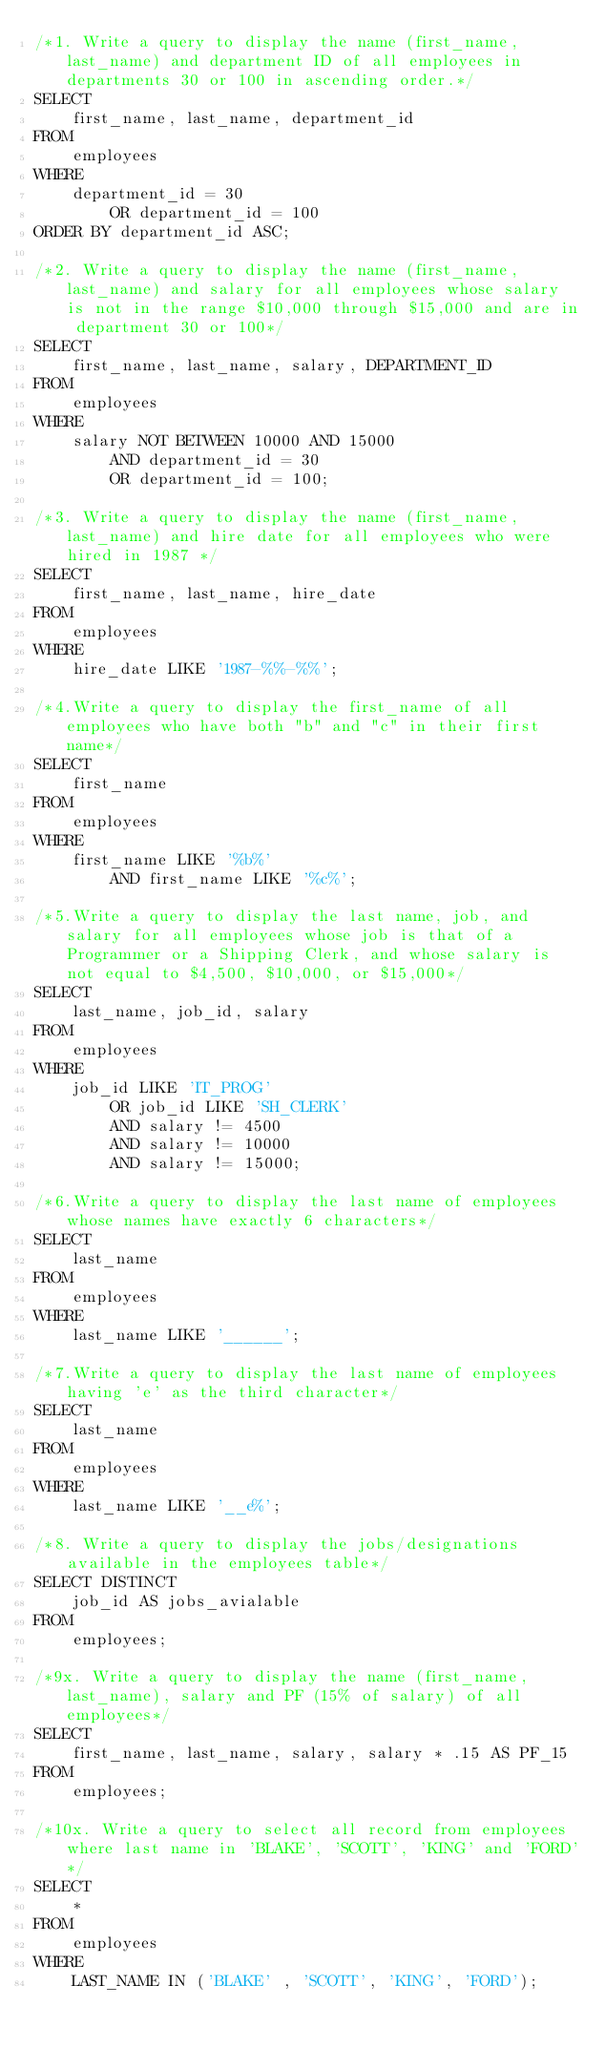<code> <loc_0><loc_0><loc_500><loc_500><_SQL_>/*1. Write a query to display the name (first_name, last_name) and department ID of all employees in departments 30 or 100 in ascending order.*/
SELECT 
    first_name, last_name, department_id
FROM
    employees
WHERE
    department_id = 30
        OR department_id = 100
ORDER BY department_id ASC;

/*2. Write a query to display the name (first_name, last_name) and salary for all employees whose salary is not in the range $10,000 through $15,000 and are in department 30 or 100*/
SELECT 
    first_name, last_name, salary, DEPARTMENT_ID
FROM
    employees
WHERE
    salary NOT BETWEEN 10000 AND 15000
        AND department_id = 30
        OR department_id = 100;
        
/*3. Write a query to display the name (first_name, last_name) and hire date for all employees who were hired in 1987 */
SELECT 
    first_name, last_name, hire_date
FROM
    employees
WHERE
    hire_date LIKE '1987-%%-%%';

/*4.Write a query to display the first_name of all employees who have both "b" and "c" in their first name*/
SELECT 
    first_name
FROM
    employees
WHERE
    first_name LIKE '%b%'
        AND first_name LIKE '%c%';
        
/*5.Write a query to display the last name, job, and salary for all employees whose job is that of a Programmer or a Shipping Clerk, and whose salary is not equal to $4,500, $10,000, or $15,000*/
SELECT 
    last_name, job_id, salary
FROM
    employees
WHERE
    job_id LIKE 'IT_PROG'
        OR job_id LIKE 'SH_CLERK'
        AND salary != 4500
        AND salary != 10000
        AND salary != 15000;
        
/*6.Write a query to display the last name of employees whose names have exactly 6 characters*/
SELECT 
    last_name
FROM
    employees
WHERE
    last_name LIKE '______';

/*7.Write a query to display the last name of employees having 'e' as the third character*/
SELECT 
    last_name
FROM
    employees
WHERE
    last_name LIKE '__e%';
    
/*8. Write a query to display the jobs/designations available in the employees table*/
SELECT DISTINCT
    job_id AS jobs_avialable
FROM
    employees;
    
/*9x. Write a query to display the name (first_name, last_name), salary and PF (15% of salary) of all employees*/
SELECT 
    first_name, last_name, salary, salary * .15 AS PF_15
FROM
    employees;
    
/*10x. Write a query to select all record from employees where last name in 'BLAKE', 'SCOTT', 'KING' and 'FORD'*/
SELECT 
    *
FROM
    employees
WHERE
    LAST_NAME IN ('BLAKE' , 'SCOTT', 'KING', 'FORD');</code> 